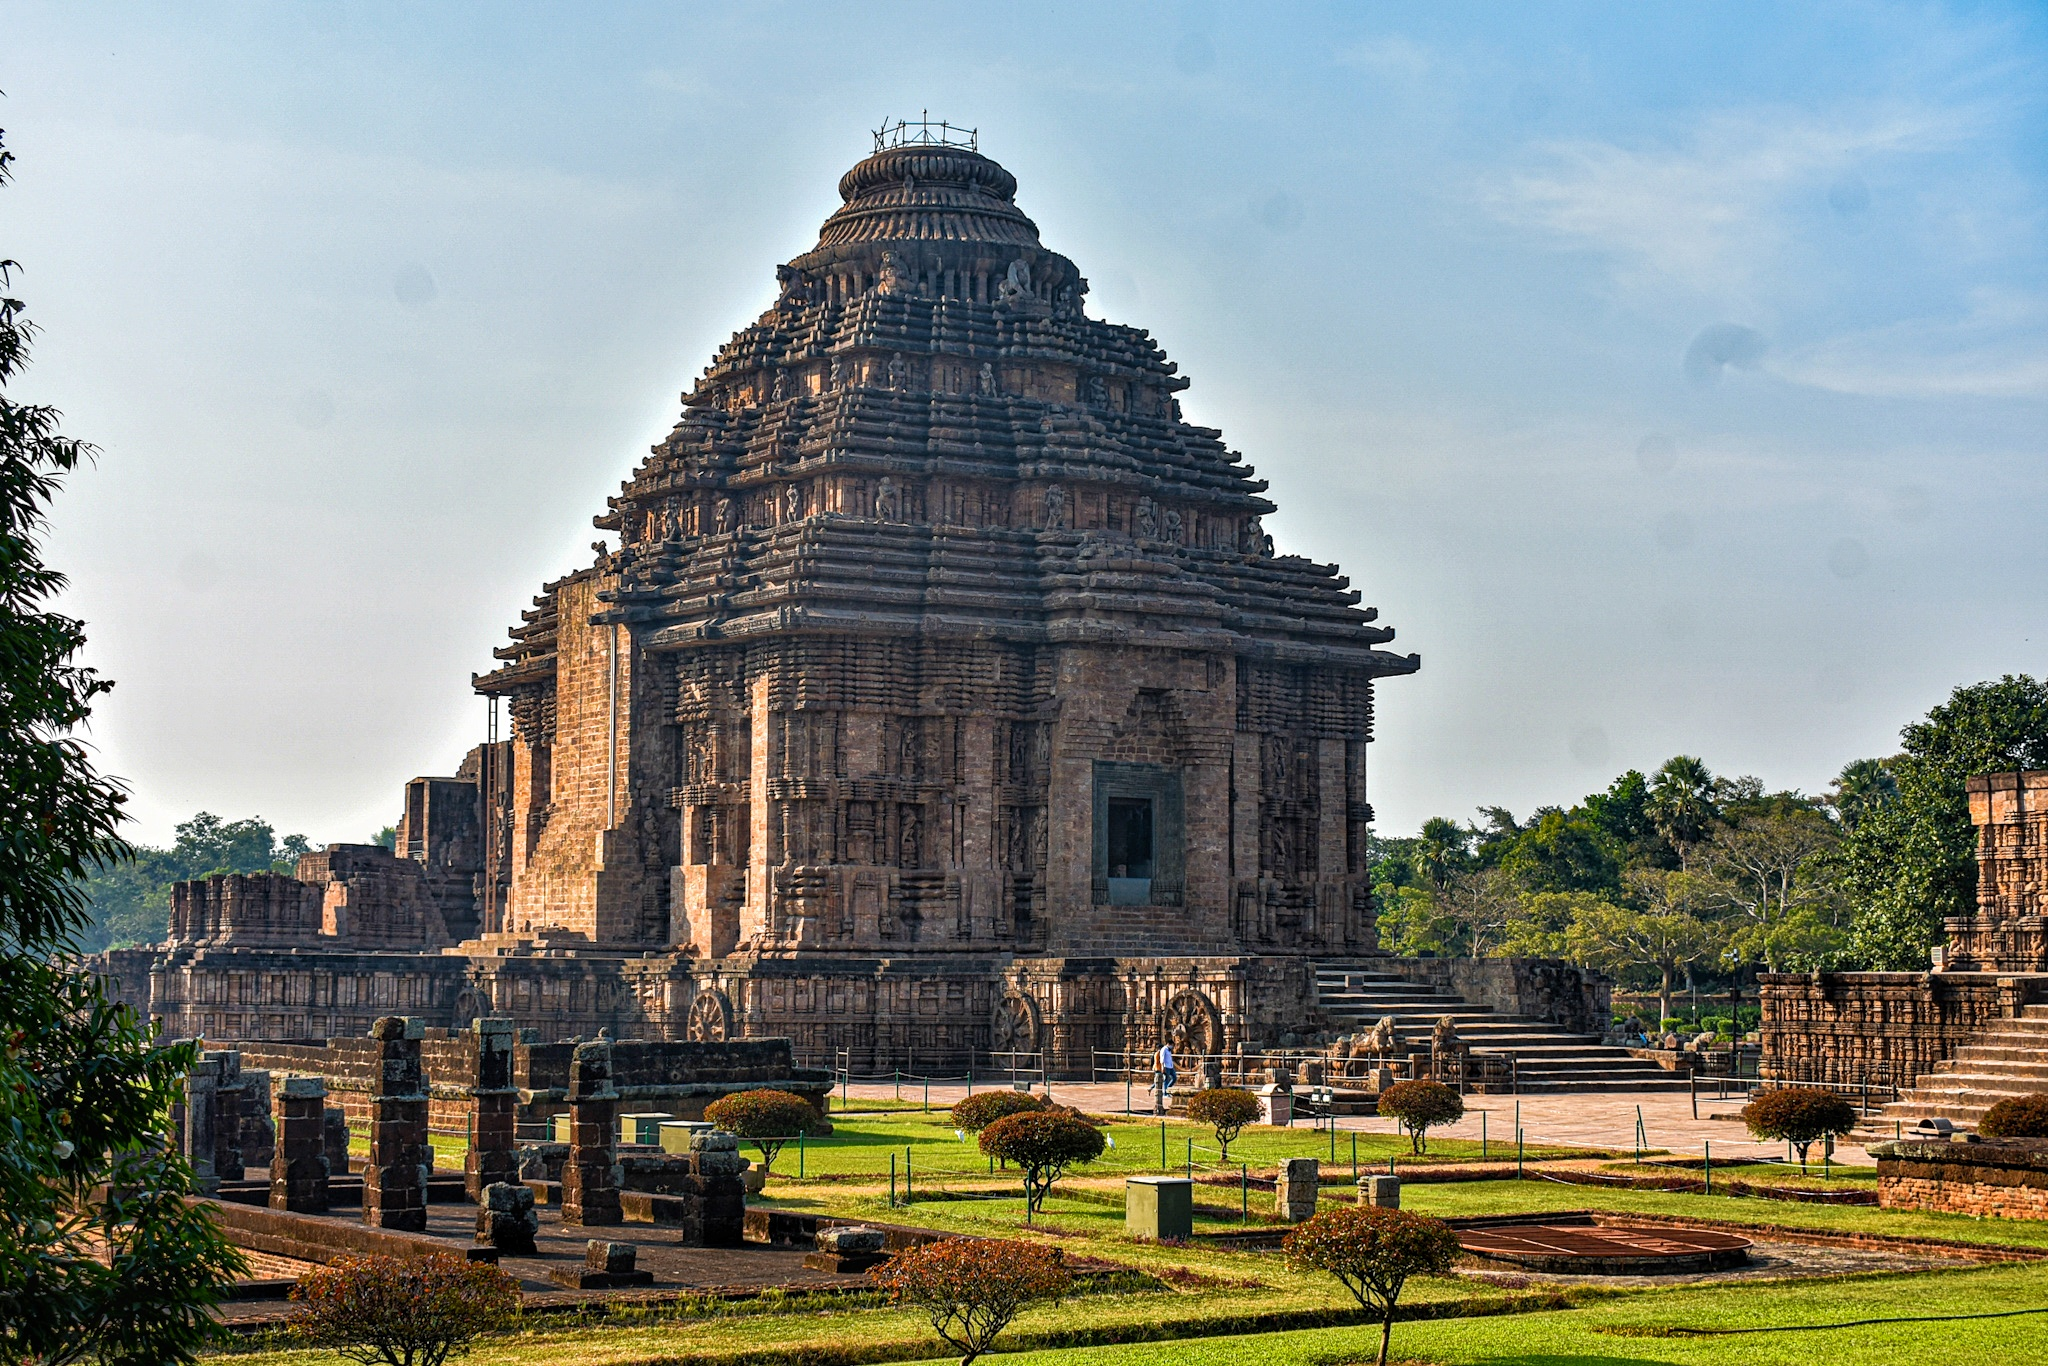What are the key elements in this picture? The image captures the majestic Konark Sun Temple in Odisha, India, a 13th-century marvel of Hindu architecture. Built in the form of the sun god Surya's chariot, it features intricately carved stone wheels, each richly decorated with symbolic motifs reflecting Hindu mythology. The temple's structure includes a vast complex with a main sanctum, which is now partially in ruins but still displays exquisite carvings of warriors, horses, and floral patterns that narrate stories from ancient texts. The grandeur of the temple is enhanced by the surrounding gardens and the detailed stonework that provides insight into the craftsmanship of the era. Moreover, the temple serves not just as a spiritual hub but also a significant astronomical instrument, designed to catch the first rays of the rising sun on its main entrance, symbolizing the victory of light over darkness. 